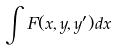Convert formula to latex. <formula><loc_0><loc_0><loc_500><loc_500>\int F ( x , y , y ^ { \prime } ) d x</formula> 